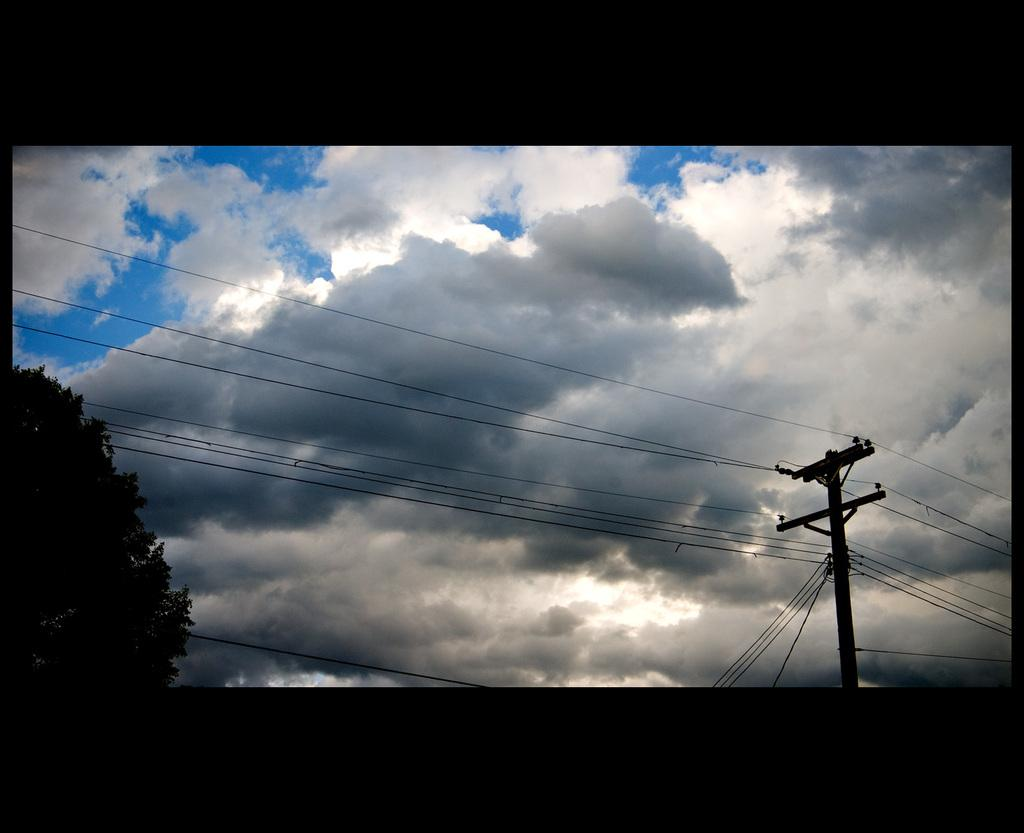What is the main object in the image? There is a current pole in the image. What else can be seen connected to the current pole? There are wires in the image. What natural element is present in the image? There is a tree in the image. What is visible in the background of the image? The sky is visible in the image, and clouds are present in the sky. How would you describe the overall lighting in the image? The background of the image appears dark. Can you tell me how many holes are in the tree in the image? There is no mention of holes in the tree in the image; it is a solid tree trunk. Who is the expert in the image? There is no expert present in the image; it features a current pole, wires, a tree, and the sky. 